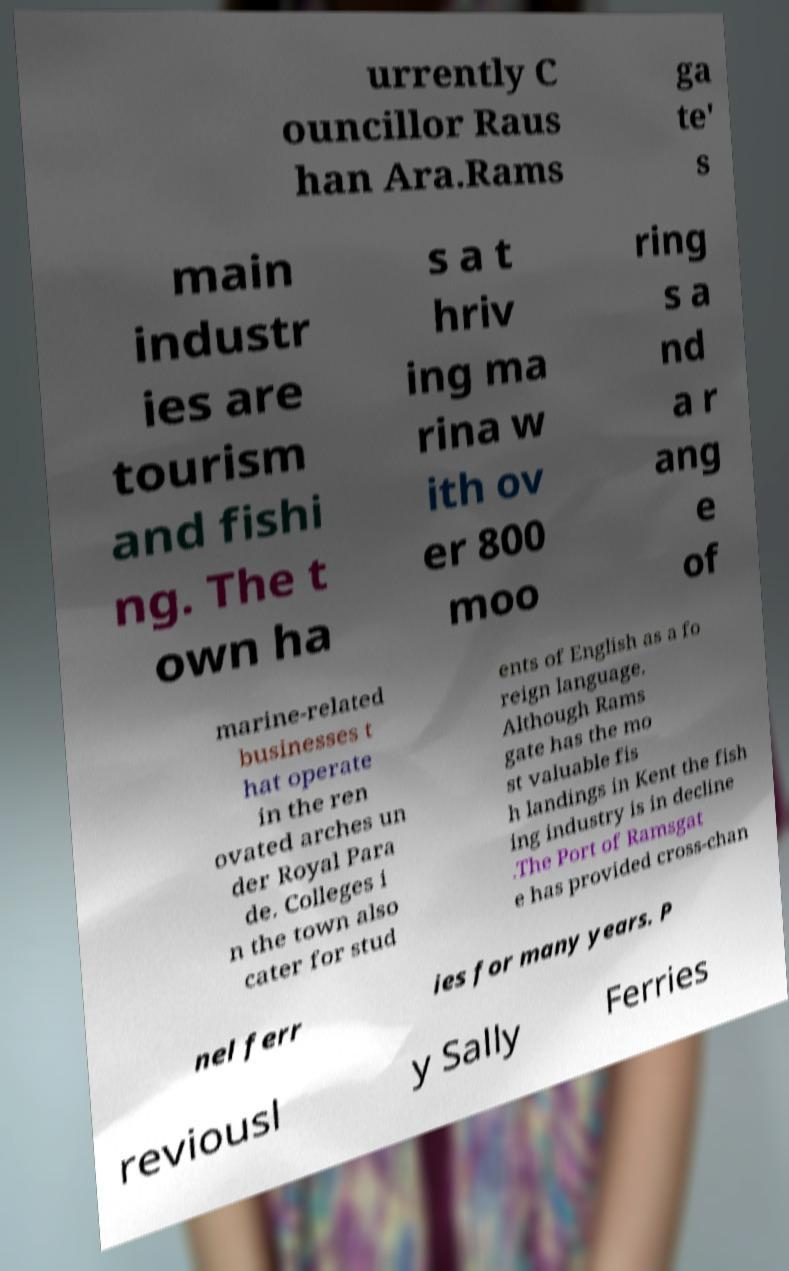Can you accurately transcribe the text from the provided image for me? urrently C ouncillor Raus han Ara.Rams ga te' s main industr ies are tourism and fishi ng. The t own ha s a t hriv ing ma rina w ith ov er 800 moo ring s a nd a r ang e of marine-related businesses t hat operate in the ren ovated arches un der Royal Para de. Colleges i n the town also cater for stud ents of English as a fo reign language. Although Rams gate has the mo st valuable fis h landings in Kent the fish ing industry is in decline .The Port of Ramsgat e has provided cross-chan nel ferr ies for many years. P reviousl y Sally Ferries 